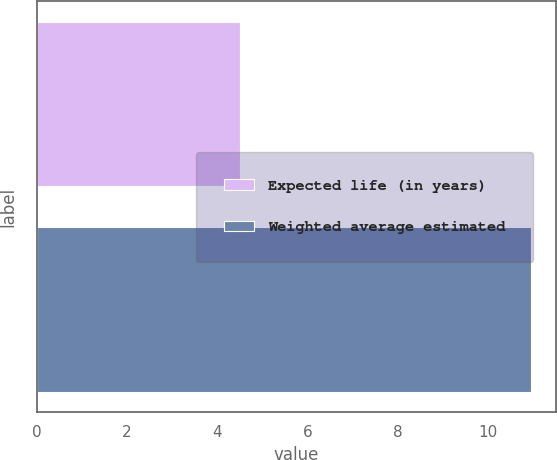<chart> <loc_0><loc_0><loc_500><loc_500><bar_chart><fcel>Expected life (in years)<fcel>Weighted average estimated<nl><fcel>4.5<fcel>10.95<nl></chart> 